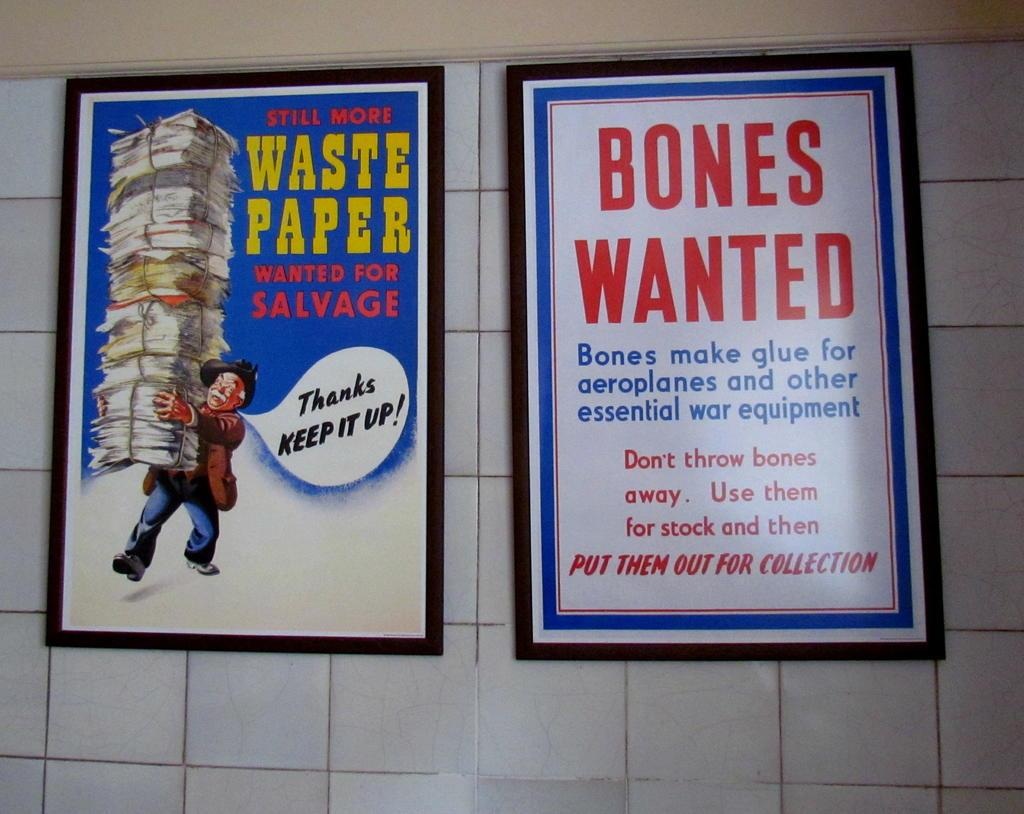<image>
Relay a brief, clear account of the picture shown. Two posters with one that says Bones Wanted on it. 